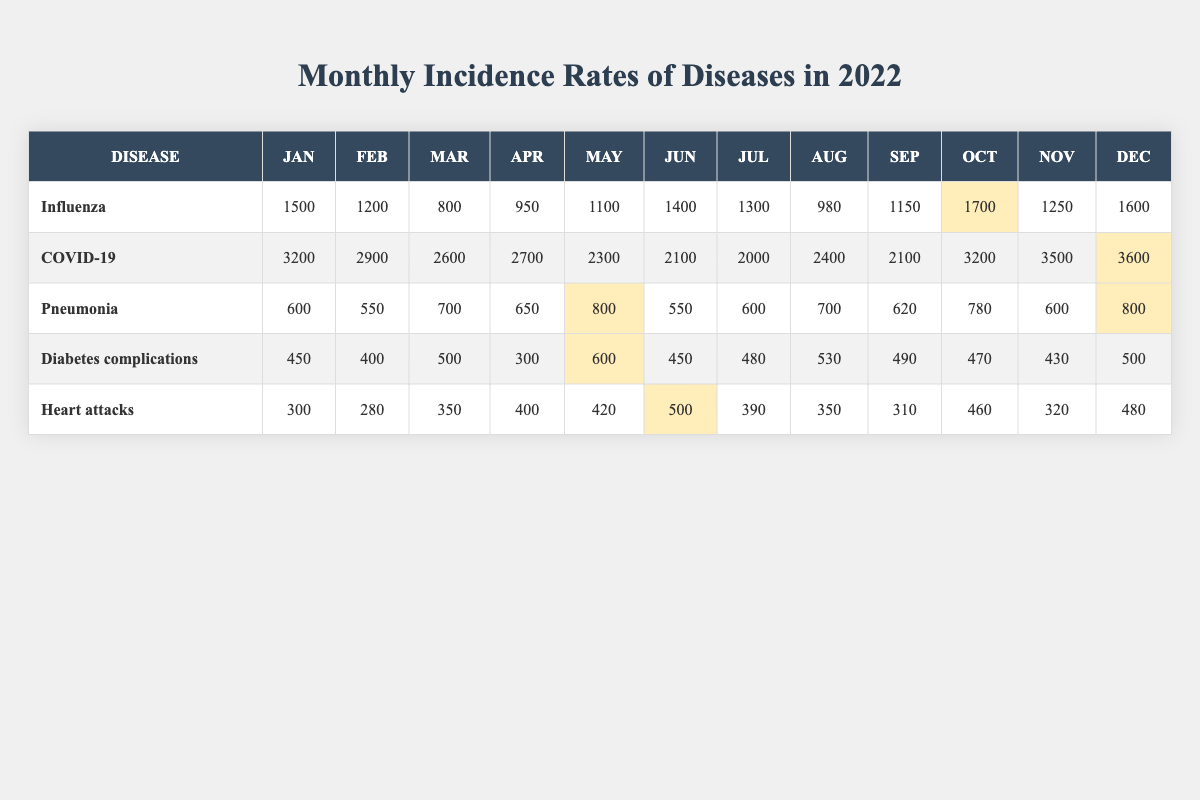What's the highest incidence rate of COVID-19 in December? The table shows that in December, the incidence rate of COVID-19 was 3600.
Answer: 3600 What was the incidence rate of influenza in March? Referring directly to the table, the incidence rate of influenza in March is listed as 800.
Answer: 800 Which disease had the highest incidence in January? By comparing the values in January, COVID-19 has the highest incidence at 3200, which is greater than the others listed for that month.
Answer: COVID-19 What is the average incidence of heart attacks over the months? To find the average, I add up the monthly incidence rates for heart attacks: (300 + 280 + 350 + 400 + 420 + 500 + 390 + 350 + 310 + 460 + 320 + 480) =  4710. Then I divide by the number of months, which is 12, giving an average of 4710/12 ≈ 392.5.
Answer: 392.5 Did the pneumonia incidence peak in May? By examining the values for pneumonia, the peak was 800 in May, and no other month exceeds this value, confirming that May was indeed the peak month.
Answer: Yes Which month saw the largest increase in COVID-19 cases from the previous month? Look at the rates for COVID-19 month-over-month: February (2900) to March (2600) shows a decrease, while March to April (2700) is an increase of 100, and other months fluctuate. October to November explodes from 3200 in October to 3500 in November, showing an increase of 300. November to December shows the biggest jump from 3500 to 3600, which is 100. Overall, October to November’s high increase is 300. The largest single increase is from October to November with 300 incidence increase.
Answer: October to November What is the total incidence for diabetes complications for the whole year? I calculate the total by summing the monthly figures: (450 + 400 + 500 + 300 + 600 + 450 + 480 + 530 + 490 + 470 + 430 + 500) =  5220.
Answer: 5220 Is the incidence of influenza in December higher than in October? The table shows influenza in December (1600) which is lower than in October (1700), thus making the statement false.
Answer: No Which disease had the lowest incidence rate in June? By observing the table for June, the incidences are as follows: Influenza (1400), COVID-19 (2100), Pneumonia (550), Diabetes complications (450), and Heart attacks (500). The lowest incidence is diabetes complications at 450.
Answer: Diabetes complications 